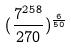Convert formula to latex. <formula><loc_0><loc_0><loc_500><loc_500>( \frac { 7 ^ { 2 5 8 } } { 2 7 0 } ) ^ { \frac { 6 } { 5 0 } }</formula> 